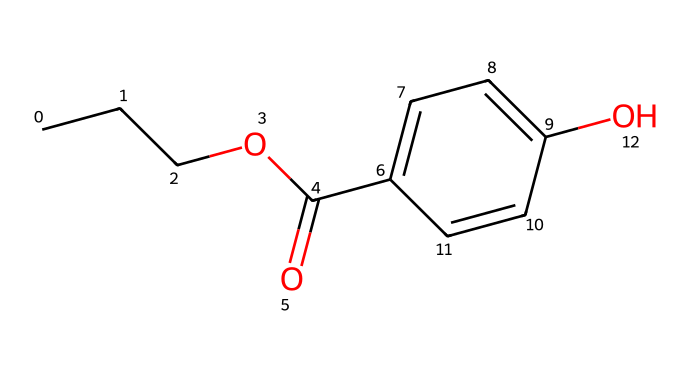What is the molecular formula of propylparaben? By analyzing the provided SMILES representation, we can sum up the number of each type of atom present in the structure. The formula consists of 10 carbon (C) atoms, 12 hydrogen (H) atoms, and 3 oxygen (O) atoms, which together form the molecular formula C10H12O3.
Answer: C10H12O3 How many rings are present in this chemical structure? Reviewing the SMILES representation, it shows a cyclic structure which consists of one aromatic ring. As there are no other closed loops mentioned, the total count of rings is one.
Answer: 1 What type of functional group is present in propylparaben? In the SMILES representation, we can identify that there is a carbonyl (C=O) and an ester (C(O)C) functional group, indicating the presence of a carboxylic acid derivative. The hydroxyl (-OH) group is also visible, confirming the presence of an aromatic alcohol, specifically a phenolic compound.
Answer: ester How many hydroxyl groups are present in this chemical? The structure contains one hydroxyl group (as indicated by the -OH part of the aromatic section in the SMILES). Thus, when counting these groups in the chemical's representation, we find only one.
Answer: 1 Is propylparaben hydrophilic or hydrophobic? Considering the composition of propylparaben, the presence of a hydroxyl group and its molecular structure indicate it has both hydrophilic (due to the -OH) and hydrophobic regions (the alkyl chain). However, the hydroxyl group typically imparts a greater hydrophilicity to the molecule.
Answer: hydrophilic How many double bonds are present in propylparaben? By examining the structure in the SMILES notation, we can spot the double bonds: one between the carbonyl carbon and its oxygen, and several double bonds within the aromatic ring. In total, there are three double bonds present in this chemical structure.
Answer: 3 